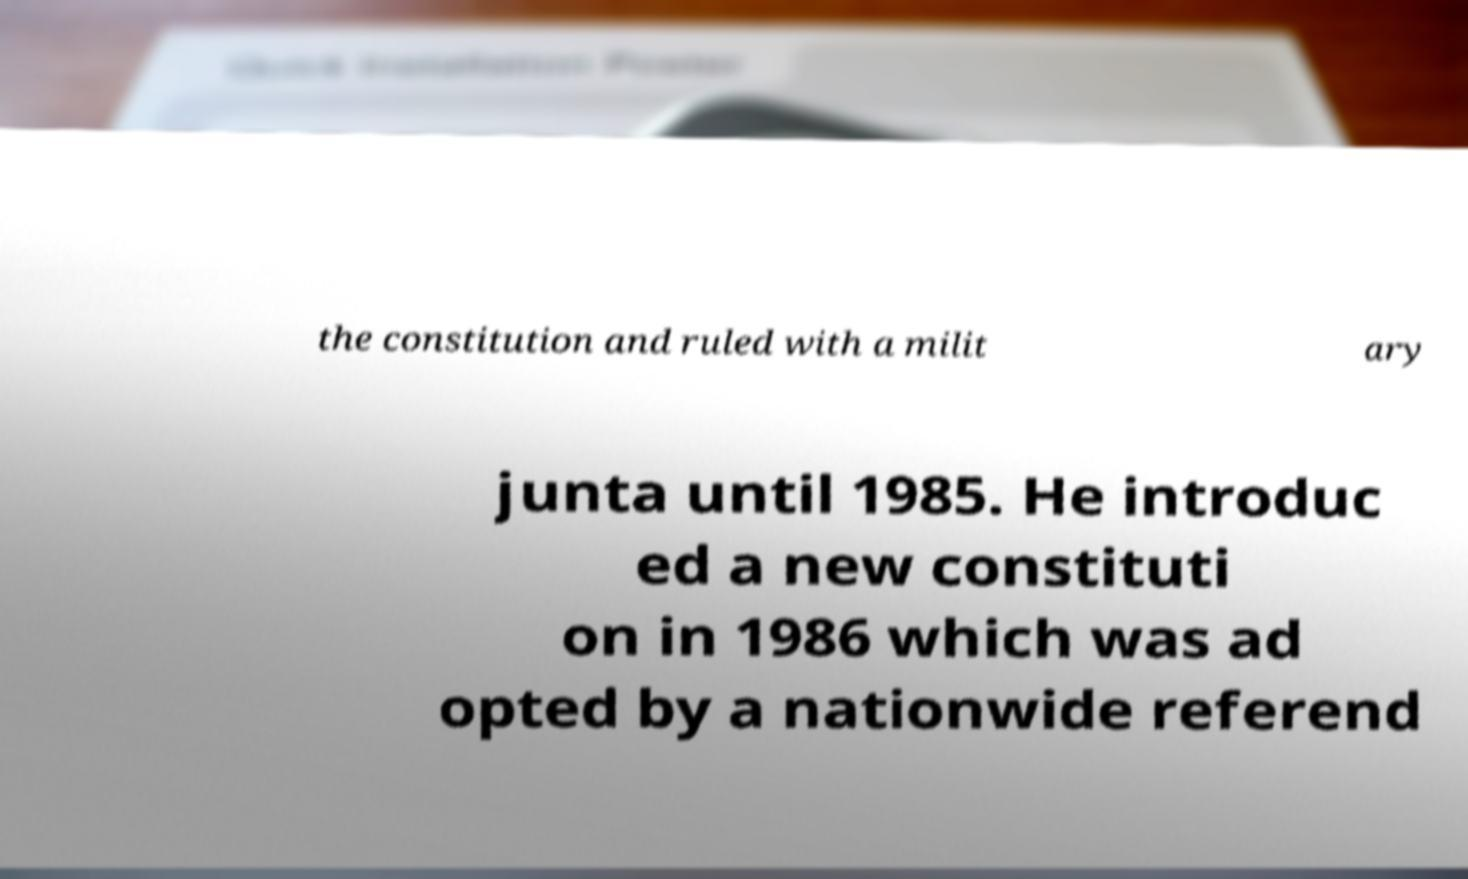Please read and relay the text visible in this image. What does it say? the constitution and ruled with a milit ary junta until 1985. He introduc ed a new constituti on in 1986 which was ad opted by a nationwide referend 